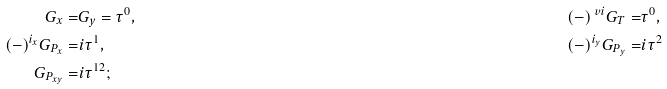<formula> <loc_0><loc_0><loc_500><loc_500>G _ { x } = & G _ { y } = \tau ^ { 0 } , & ( - ) ^ { \ v i } G _ { T } = & \tau ^ { 0 } , \\ ( - ) ^ { i _ { x } } G _ { P _ { x } } = & i \tau ^ { 1 } , & ( - ) ^ { i _ { y } } G _ { P _ { y } } = & i \tau ^ { 2 } \\ G _ { P _ { x y } } = & i \tau ^ { 1 2 } ;</formula> 